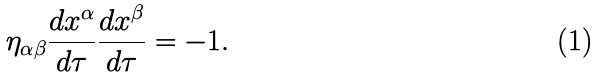Convert formula to latex. <formula><loc_0><loc_0><loc_500><loc_500>\eta _ { \alpha \beta } \frac { d x ^ { \alpha } } { d \tau } \frac { d x ^ { \beta } } { d \tau } = - 1 .</formula> 